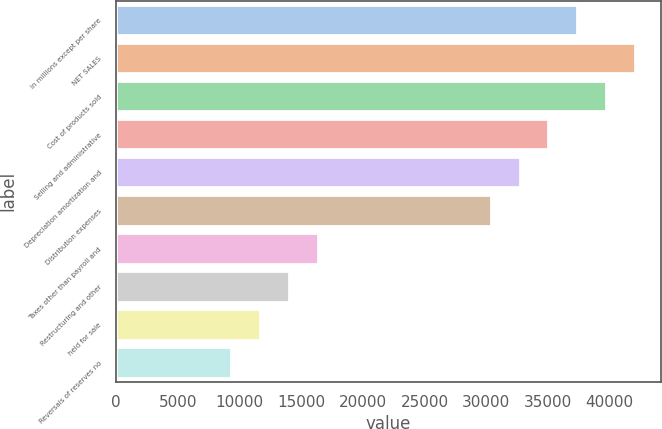Convert chart to OTSL. <chart><loc_0><loc_0><loc_500><loc_500><bar_chart><fcel>In millions except per share<fcel>NET SALES<fcel>Cost of products sold<fcel>Selling and administrative<fcel>Depreciation amortization and<fcel>Distribution expenses<fcel>Taxes other than payroll and<fcel>Restructuring and other<fcel>held for sale<fcel>Reversals of reserves no<nl><fcel>37374.3<fcel>42046.1<fcel>39710.2<fcel>35038.4<fcel>32702.5<fcel>30366.6<fcel>16351.3<fcel>14015.4<fcel>11679.5<fcel>9343.63<nl></chart> 